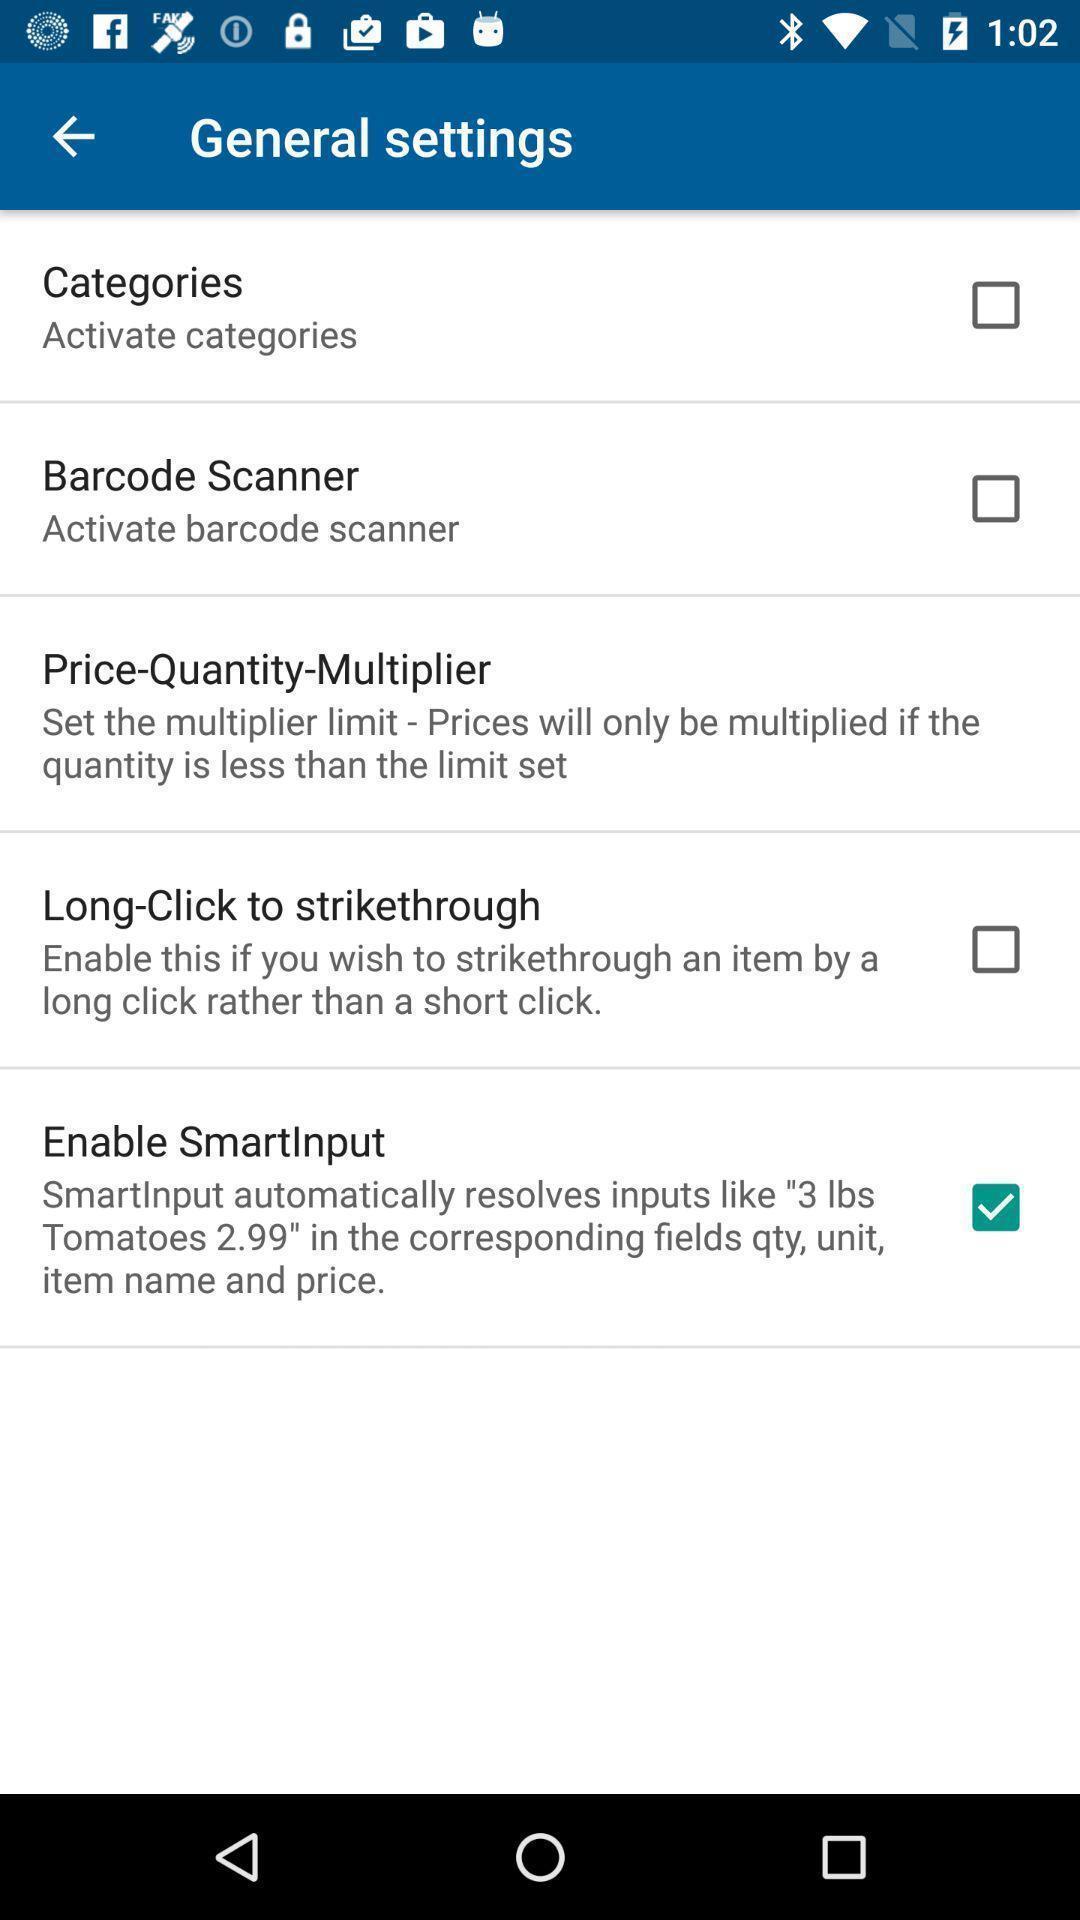Describe the content in this image. Page displaying list of settings in a shopping application. 